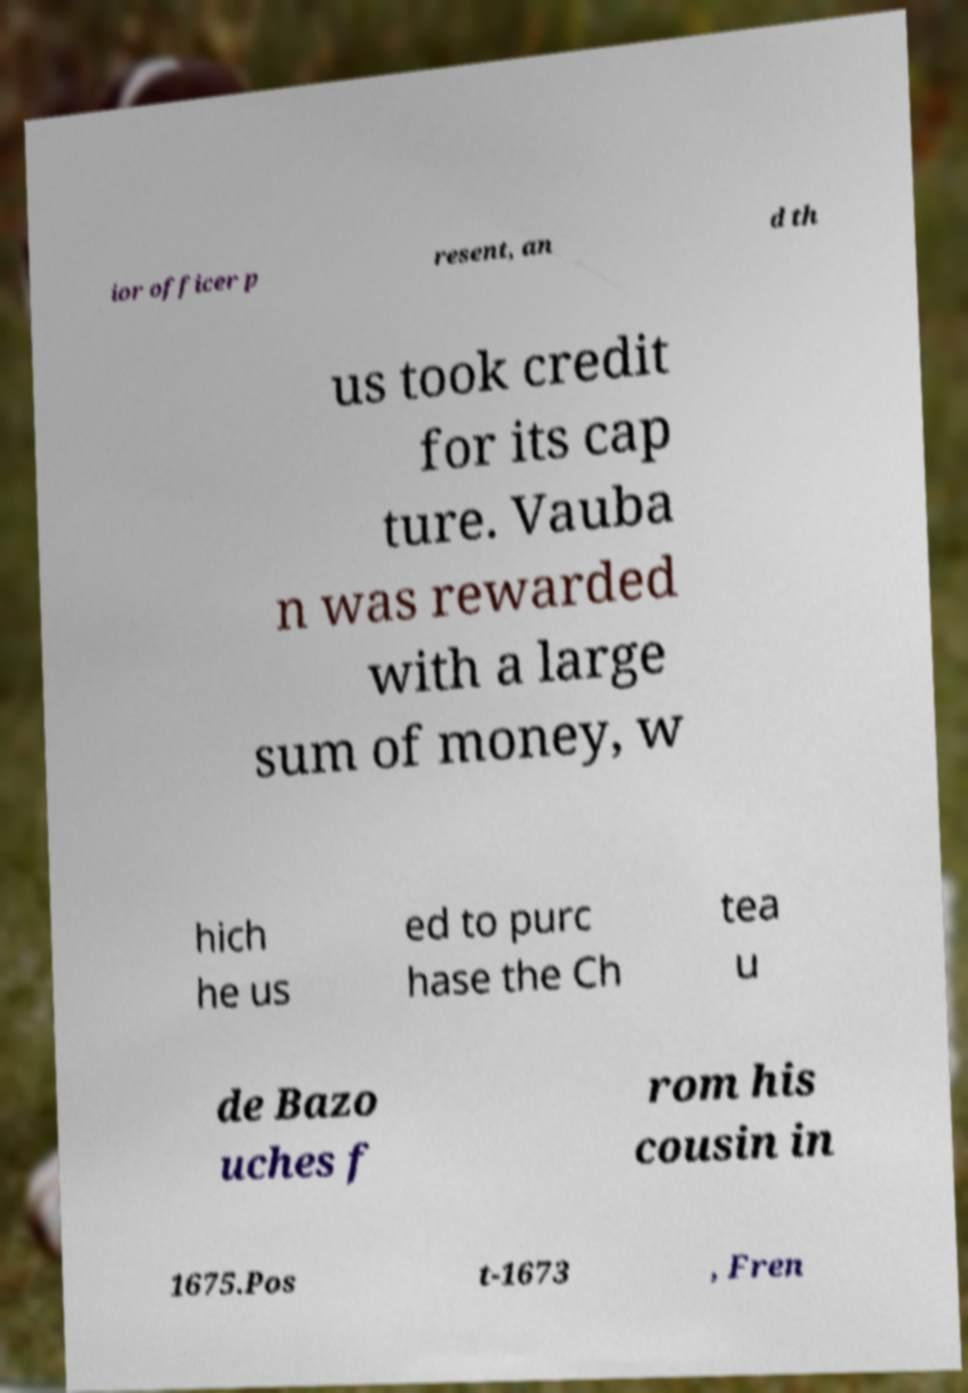Can you read and provide the text displayed in the image?This photo seems to have some interesting text. Can you extract and type it out for me? ior officer p resent, an d th us took credit for its cap ture. Vauba n was rewarded with a large sum of money, w hich he us ed to purc hase the Ch tea u de Bazo uches f rom his cousin in 1675.Pos t-1673 , Fren 